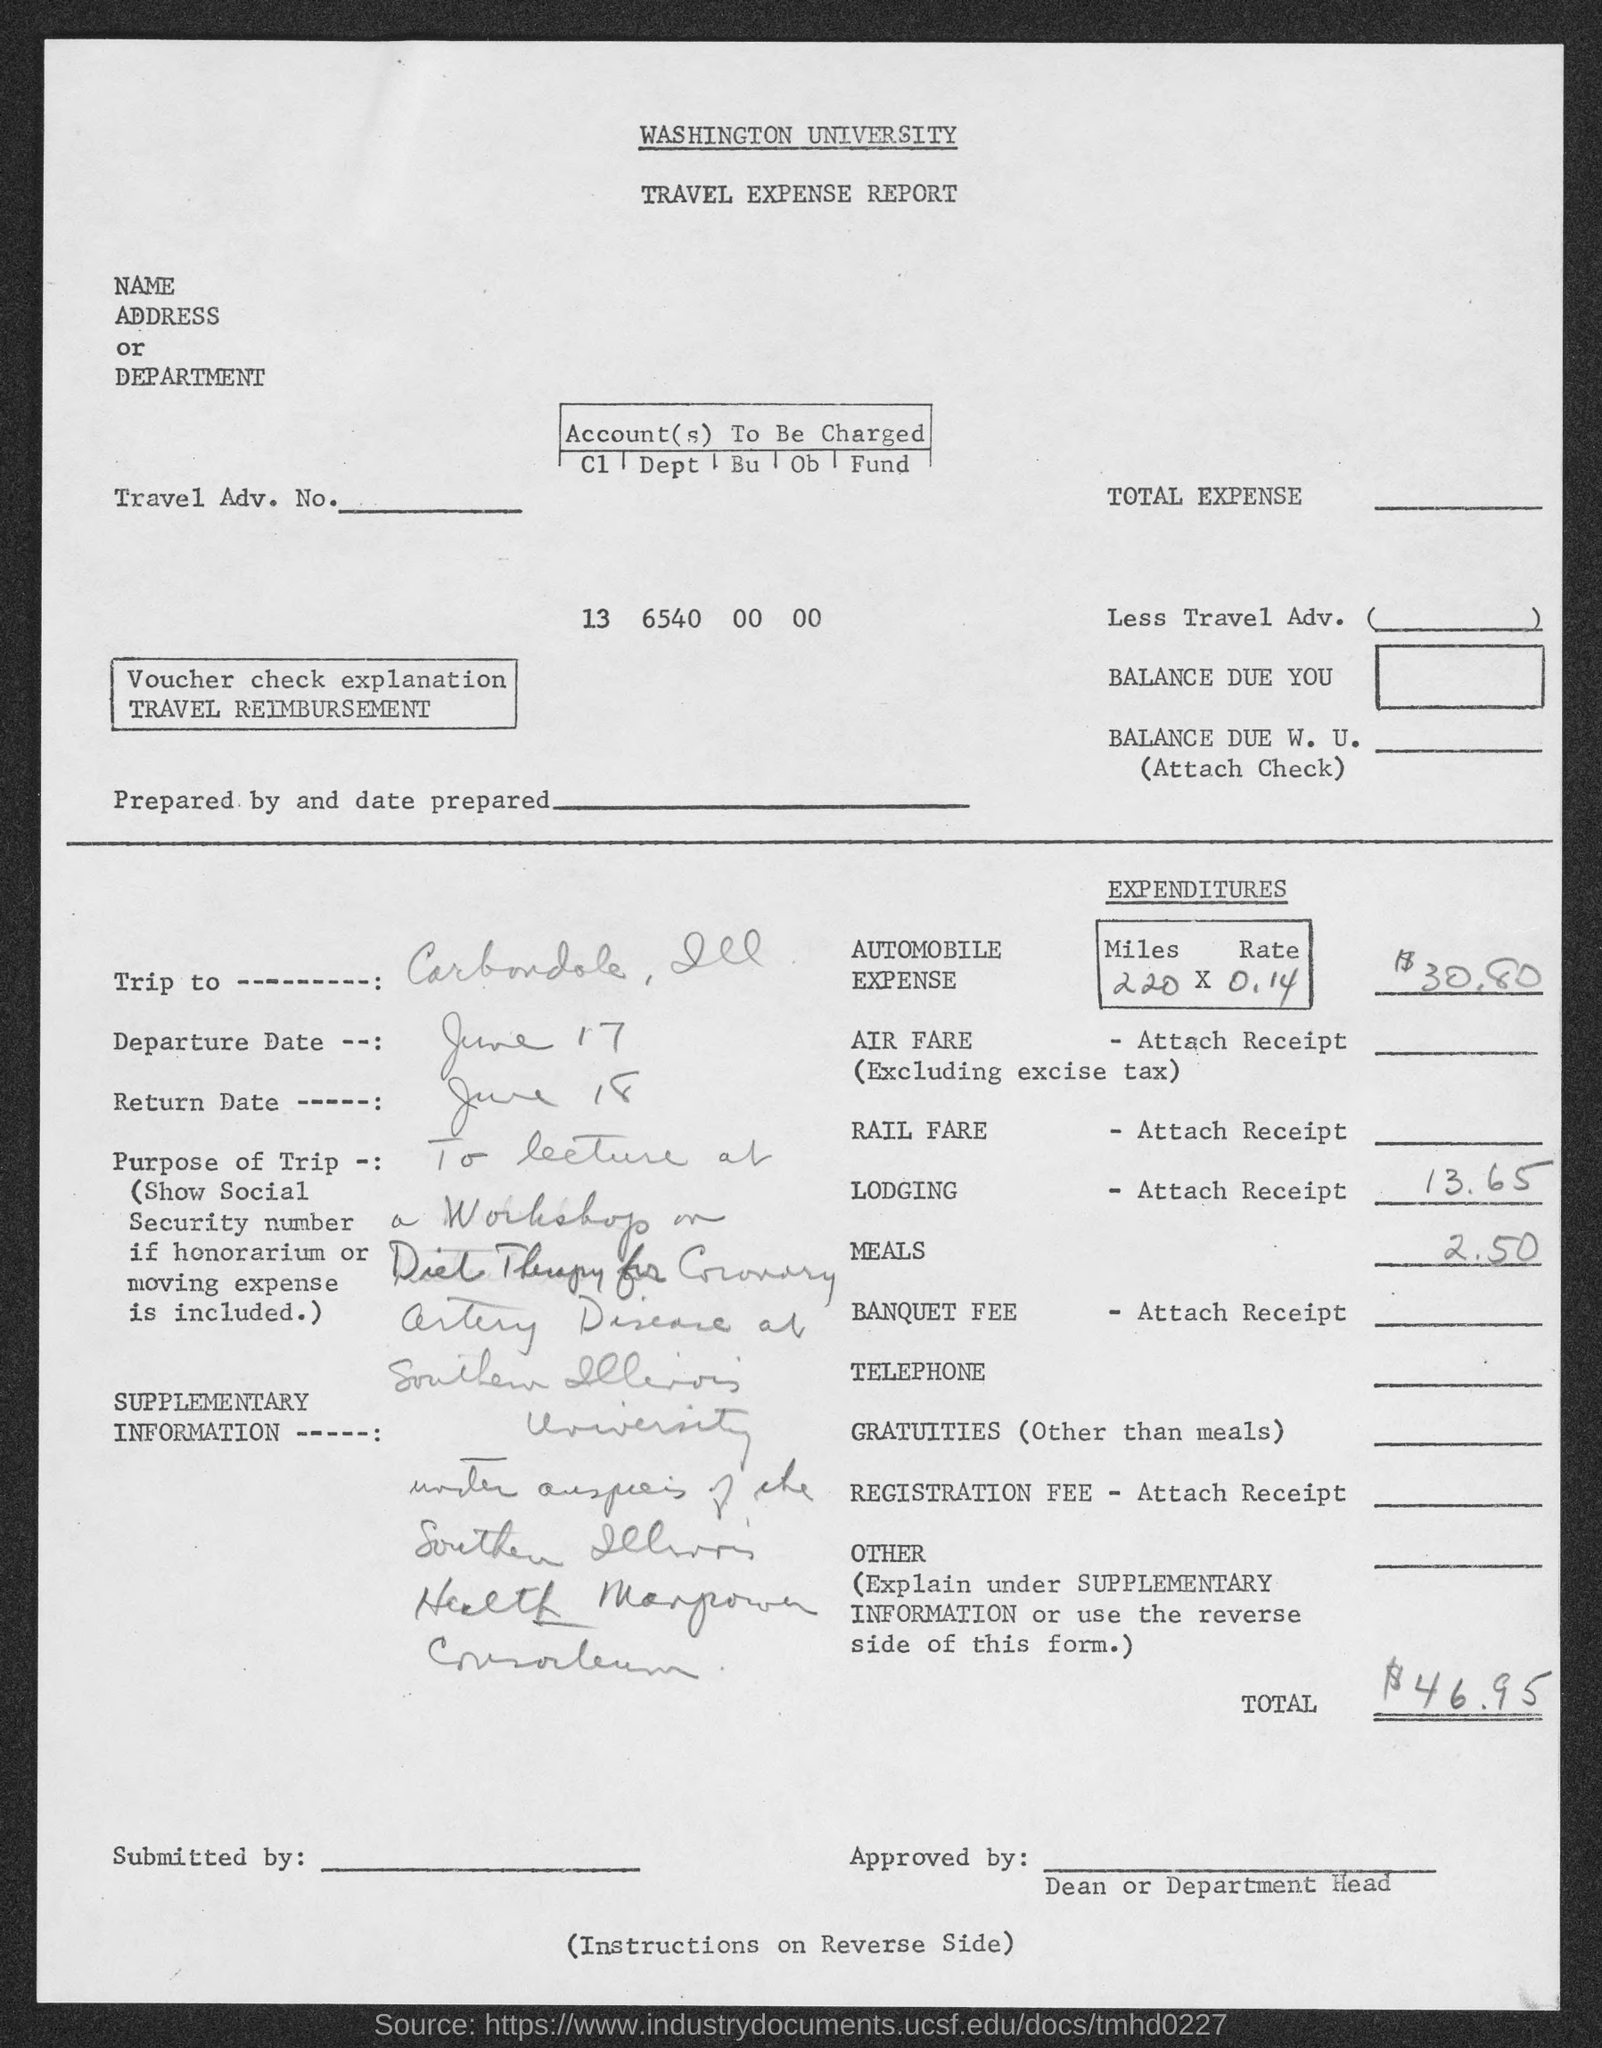What is the departure date given in the travel expense report?
Give a very brief answer. June 17. What is the return date given in the travel expense report?
Your response must be concise. June 18. What is the total expenditure given in the travel expense report?
Your answer should be very brief. $46.95. Which university's travel expense report is given here?
Offer a very short reply. Washington University. What is the automobile expense given in the travel expense report?
Your answer should be compact. $30.80. 